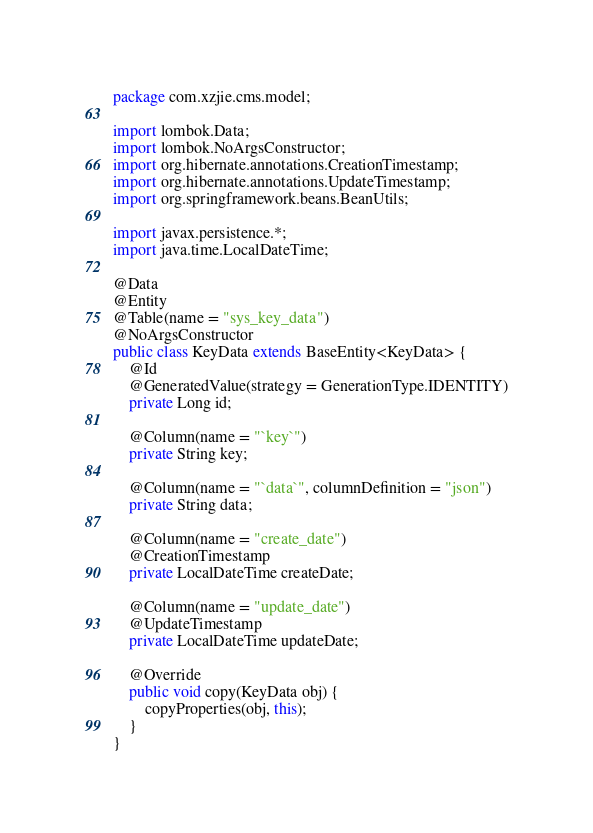<code> <loc_0><loc_0><loc_500><loc_500><_Java_>package com.xzjie.cms.model;

import lombok.Data;
import lombok.NoArgsConstructor;
import org.hibernate.annotations.CreationTimestamp;
import org.hibernate.annotations.UpdateTimestamp;
import org.springframework.beans.BeanUtils;

import javax.persistence.*;
import java.time.LocalDateTime;

@Data
@Entity
@Table(name = "sys_key_data")
@NoArgsConstructor
public class KeyData extends BaseEntity<KeyData> {
    @Id
    @GeneratedValue(strategy = GenerationType.IDENTITY)
    private Long id;

    @Column(name = "`key`")
    private String key;

    @Column(name = "`data`", columnDefinition = "json")
    private String data;

    @Column(name = "create_date")
    @CreationTimestamp
    private LocalDateTime createDate;

    @Column(name = "update_date")
    @UpdateTimestamp
    private LocalDateTime updateDate;

    @Override
    public void copy(KeyData obj) {
        copyProperties(obj, this);
    }
}
</code> 